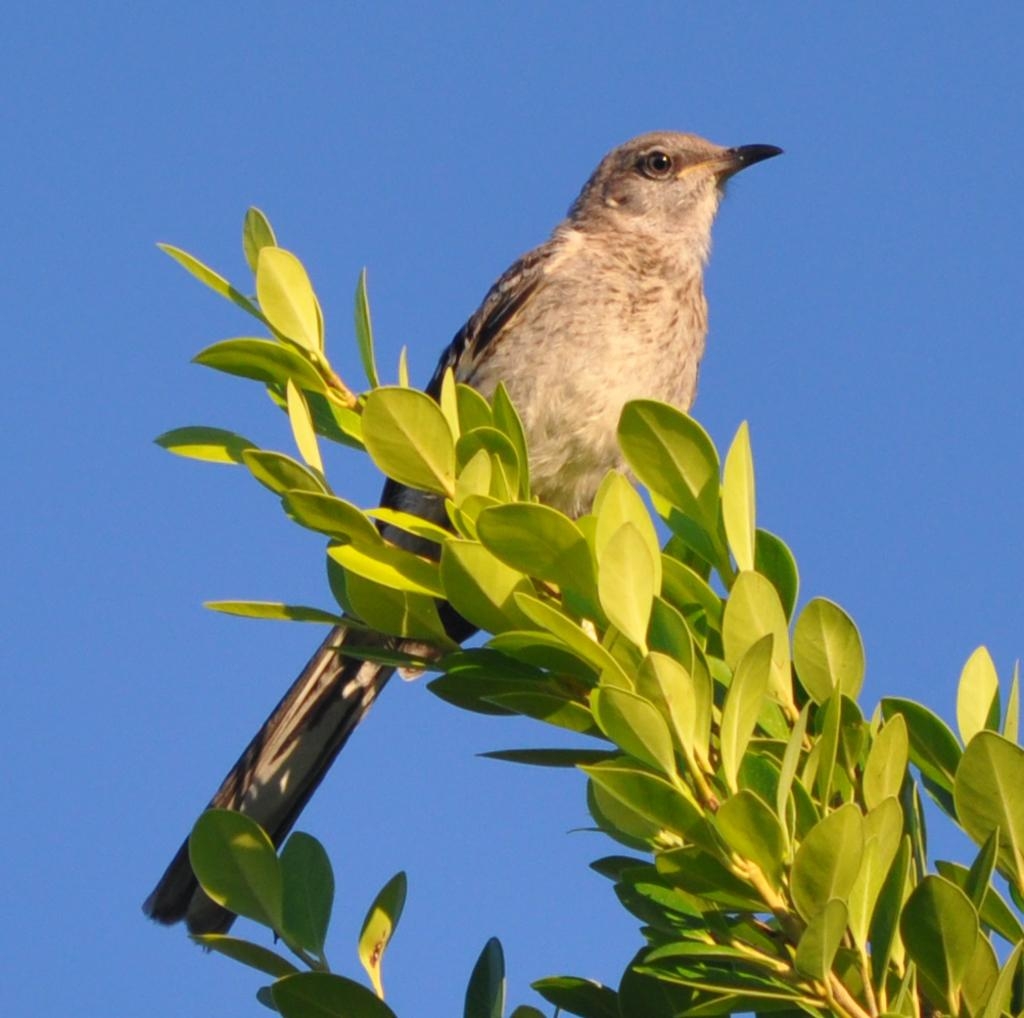What animal can be seen in the picture? There is a bird in the picture. Where is the bird located in the image? The bird is sitting on a stem. What is attached to the stem? The stem has leaves. What is the condition of the sky in the picture? The sky is clear in the picture. What religion does the bird's sister practice in the image? There is no mention of a sister or religion in the image, as it only features a bird sitting on a stem with leaves. 